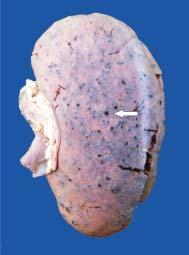what shows tiny petechial haemorrhages visible through the capsule?
Answer the question using a single word or phrase. Cortex 